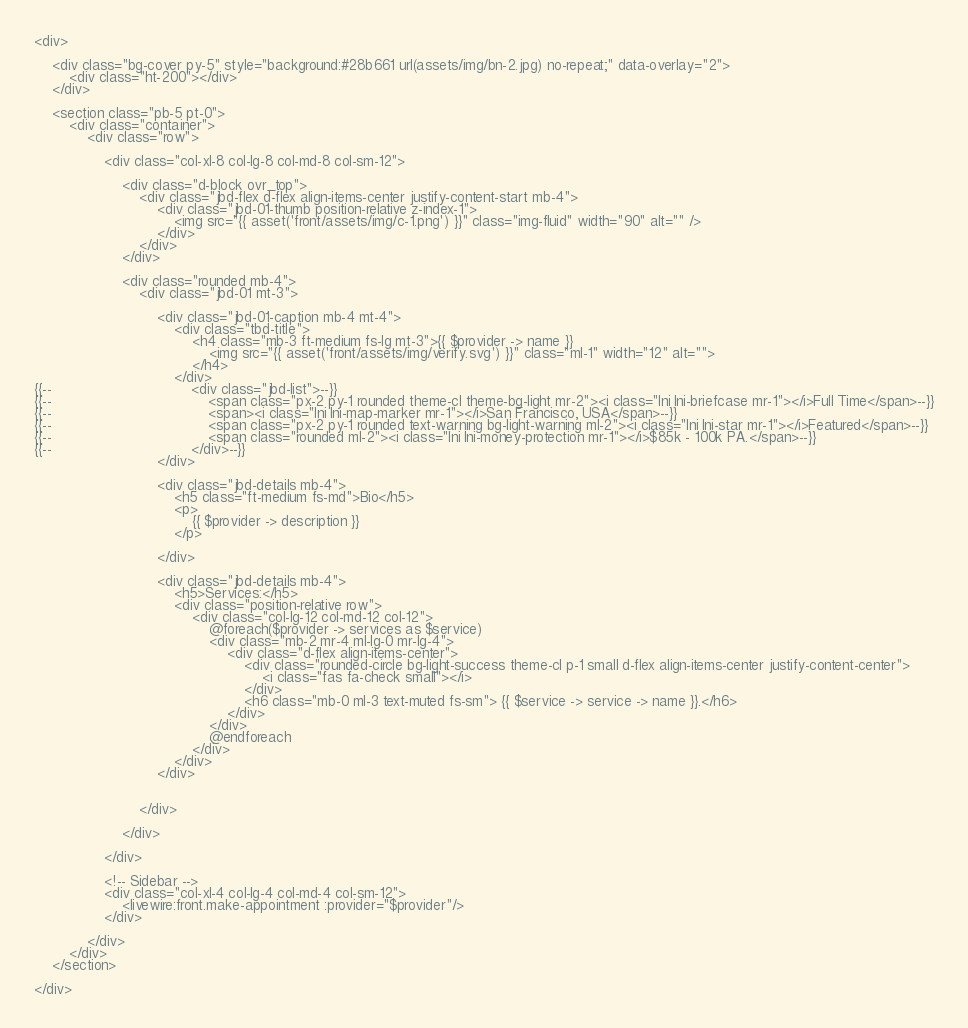Convert code to text. <code><loc_0><loc_0><loc_500><loc_500><_PHP_><div>

    <div class="bg-cover py-5" style="background:#28b661 url(assets/img/bn-2.jpg) no-repeat;" data-overlay="2">
        <div class="ht-200"></div>
    </div>

    <section class="pb-5 pt-0">
        <div class="container">
            <div class="row">

                <div class="col-xl-8 col-lg-8 col-md-8 col-sm-12">

                    <div class="d-block ovr_top">
                        <div class="jbd-flex d-flex align-items-center justify-content-start mb-4">
                            <div class="jbd-01-thumb position-relative z-index-1">
                                <img src="{{ asset('front/assets/img/c-1.png') }}" class="img-fluid" width="90" alt="" />
                            </div>
                        </div>
                    </div>

                    <div class="rounded mb-4">
                        <div class="jbd-01 mt-3">

                            <div class="jbd-01-caption mb-4 mt-4">
                                <div class="tbd-title">
                                    <h4 class="mb-3 ft-medium fs-lg mt-3">{{ $provider -> name }}
                                        <img src="{{ asset('front/assets/img/verify.svg') }}" class="ml-1" width="12" alt="">
                                    </h4>
                                </div>
{{--                                <div class="jbd-list">--}}
{{--                                    <span class="px-2 py-1 rounded theme-cl theme-bg-light mr-2"><i class="lni lni-briefcase mr-1"></i>Full Time</span>--}}
{{--                                    <span><i class="lni lni-map-marker mr-1"></i>San Francisco, USA</span>--}}
{{--                                    <span class="px-2 py-1 rounded text-warning bg-light-warning ml-2"><i class="lni lni-star mr-1"></i>Featured</span>--}}
{{--                                    <span class="rounded ml-2"><i class="lni lni-money-protection mr-1"></i>$85k - 100k PA.</span>--}}
{{--                                </div>--}}
                            </div>

                            <div class="jbd-details mb-4">
                                <h5 class="ft-medium fs-md">Bio</h5>
                                <p>
                                    {{ $provider -> description }}
                                </p>

                            </div>

                            <div class="jbd-details mb-4">
                                <h5>Services:</h5>
                                <div class="position-relative row">
                                    <div class="col-lg-12 col-md-12 col-12">
                                        @foreach($provider -> services as $service)
                                        <div class="mb-2 mr-4 ml-lg-0 mr-lg-4">
                                            <div class="d-flex align-items-center">
                                                <div class="rounded-circle bg-light-success theme-cl p-1 small d-flex align-items-center justify-content-center">
                                                    <i class="fas fa-check small"></i>
                                                </div>
                                                <h6 class="mb-0 ml-3 text-muted fs-sm"> {{ $service -> service -> name }}.</h6>
                                            </div>
                                        </div>
                                        @endforeach
                                    </div>
                                </div>
                            </div>


                        </div>

                    </div>

                </div>

                <!-- Sidebar -->
                <div class="col-xl-4 col-lg-4 col-md-4 col-sm-12">
                    <livewire:front.make-appointment :provider="$provider"/>
                </div>

            </div>
        </div>
    </section>

</div>
</code> 